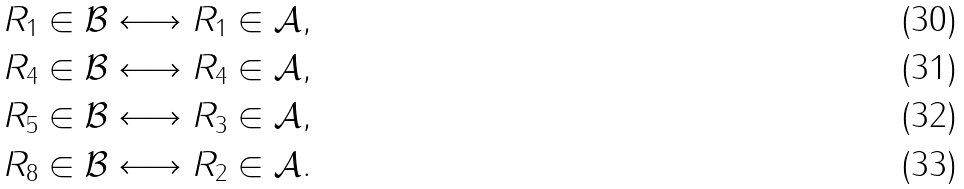Convert formula to latex. <formula><loc_0><loc_0><loc_500><loc_500>R _ { 1 } \in \mathcal { B } \longleftrightarrow R _ { 1 } \in \mathcal { A } , \\ R _ { 4 } \in \mathcal { B } \longleftrightarrow R _ { 4 } \in \mathcal { A } , \\ R _ { 5 } \in \mathcal { B } \longleftrightarrow R _ { 3 } \in \mathcal { A } , \\ R _ { 8 } \in \mathcal { B } \longleftrightarrow R _ { 2 } \in \mathcal { A } .</formula> 